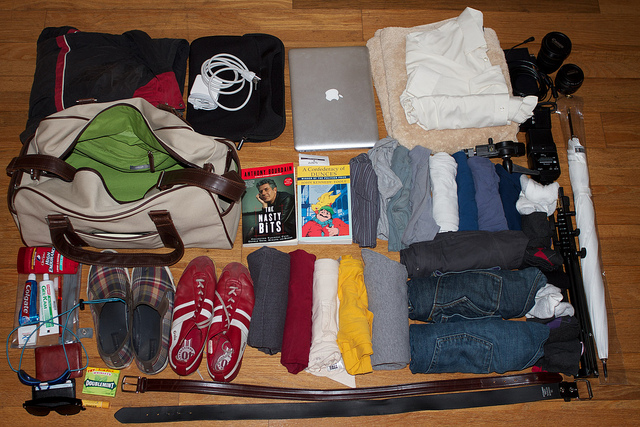Identify and read out the text in this image. BITS 